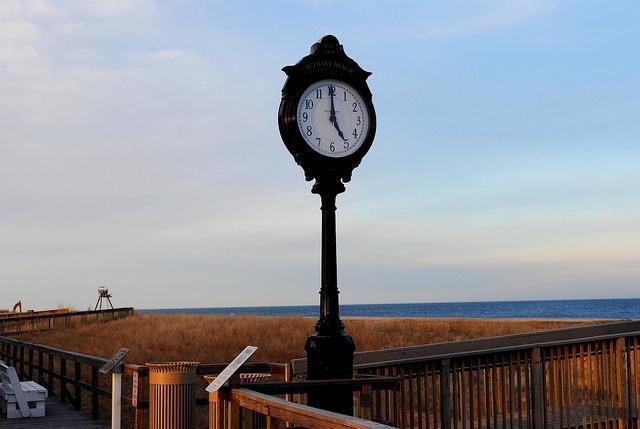How many elephants are in the picture?
Give a very brief answer. 0. 